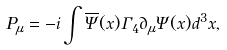Convert formula to latex. <formula><loc_0><loc_0><loc_500><loc_500>P _ { \mu } = - i \int \overline { \Psi } ( x ) \Gamma _ { 4 } \partial _ { \mu } \Psi ( x ) d ^ { 3 } x ,</formula> 